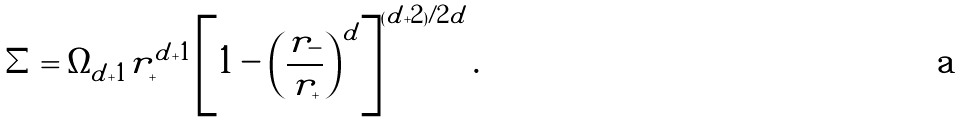Convert formula to latex. <formula><loc_0><loc_0><loc_500><loc_500>\Sigma = \Omega _ { \tilde { d } + 1 } r _ { + } ^ { \tilde { d } + 1 } \left [ 1 - \left ( \frac { r _ { - } } { r _ { + } } \right ) ^ { \tilde { d } } \right ] ^ { ( \tilde { d } + 2 ) / 2 \tilde { d } } .</formula> 